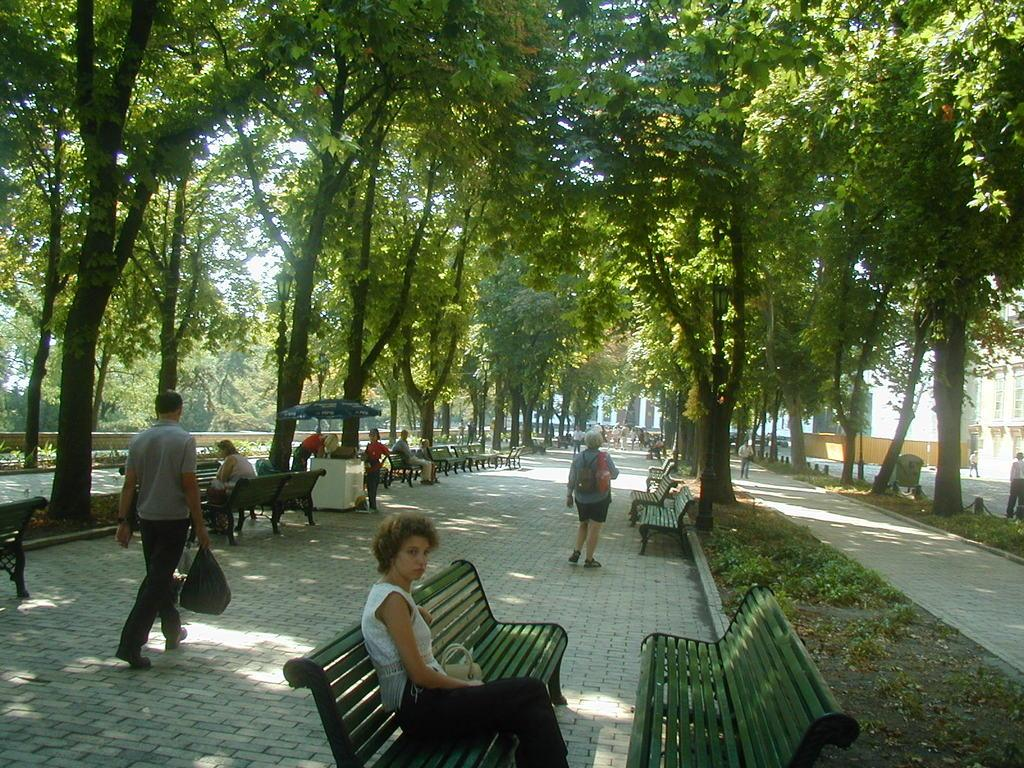What are the people in the image doing? There are persons standing and sitting on benches in the image. Can you describe the actions of one of the persons in the image? A person is walking and holding a cover. What can be seen in the background of the image? There are trees, at least one building, and benches in the background of the image. What type of vegetation is visible in the background? Plants are present in the background of the image. What is the price of the sky in the image? The sky does not have a price, as it is a natural element and not a product or service. 